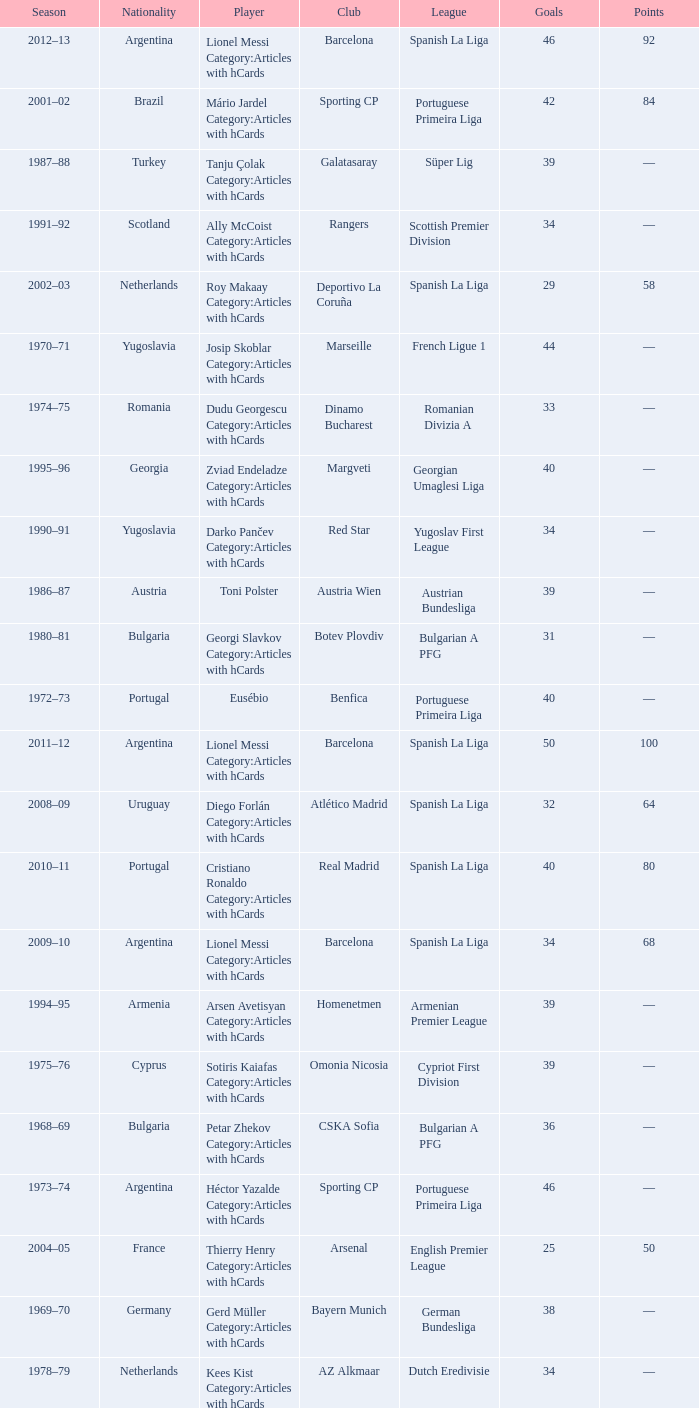Which player was in the Omonia Nicosia club? Sotiris Kaiafas Category:Articles with hCards. 